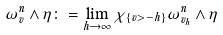<formula> <loc_0><loc_0><loc_500><loc_500>\omega ^ { n } _ { v } \wedge \eta \colon = \lim _ { h \rightarrow \infty } \chi _ { \{ v > - h \} } \omega ^ { n } _ { v _ { h } } \wedge \eta</formula> 